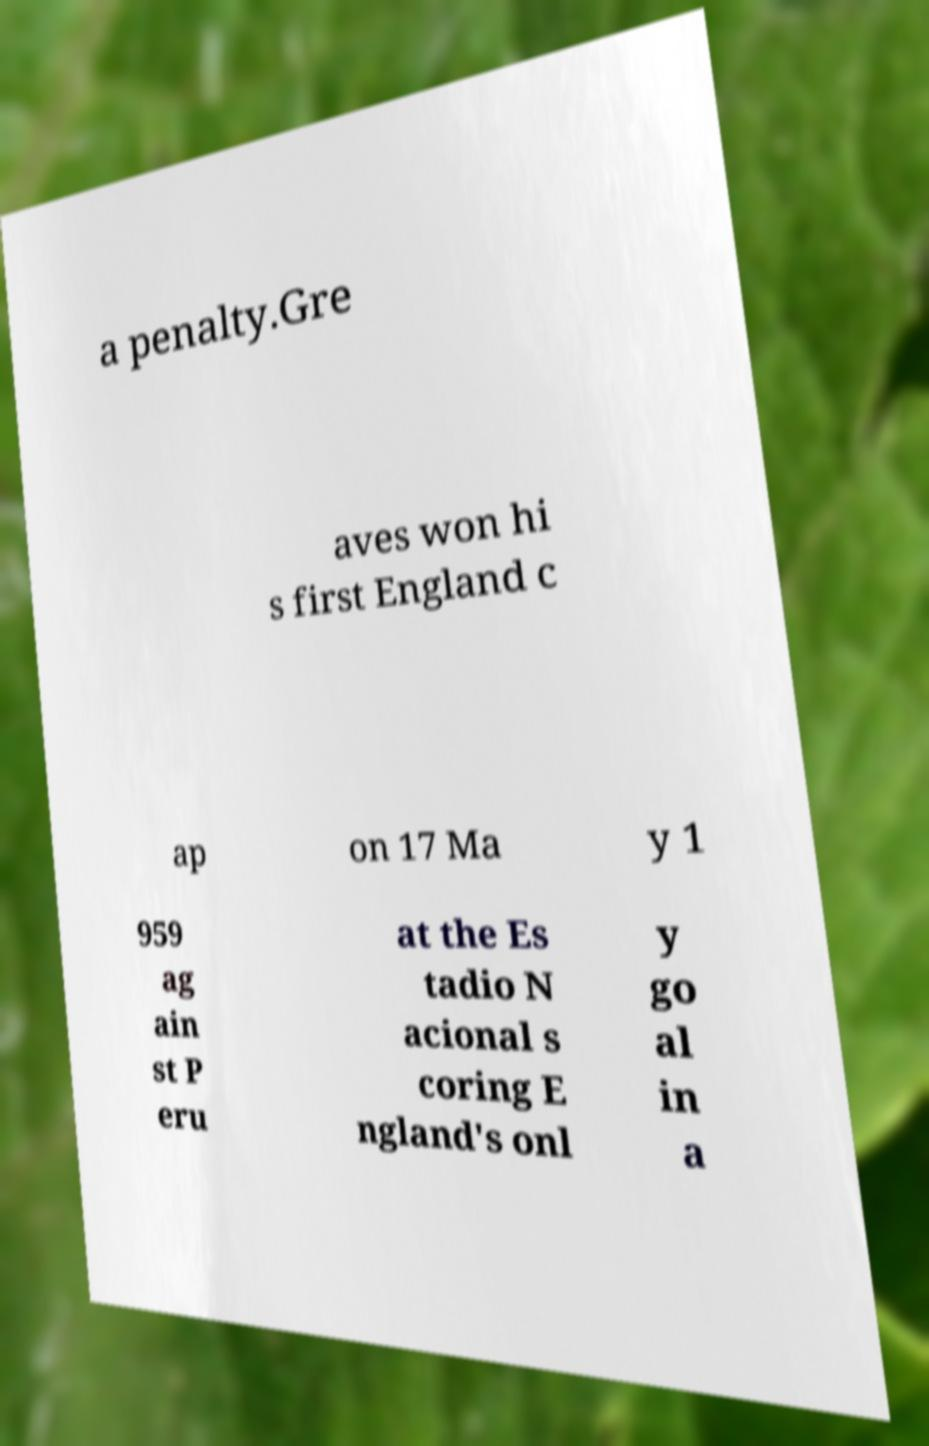Can you accurately transcribe the text from the provided image for me? a penalty.Gre aves won hi s first England c ap on 17 Ma y 1 959 ag ain st P eru at the Es tadio N acional s coring E ngland's onl y go al in a 